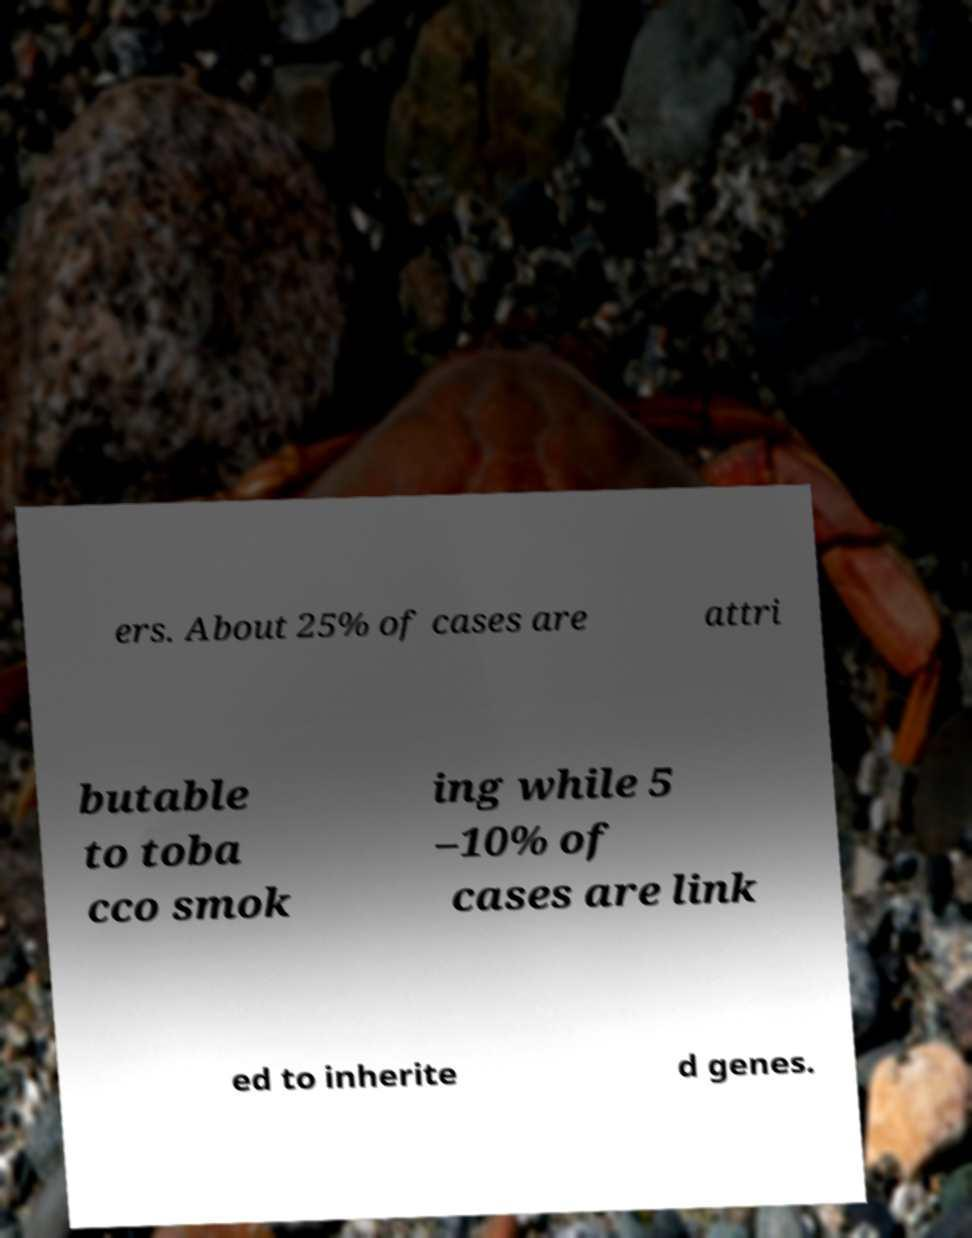Can you read and provide the text displayed in the image?This photo seems to have some interesting text. Can you extract and type it out for me? ers. About 25% of cases are attri butable to toba cco smok ing while 5 –10% of cases are link ed to inherite d genes. 